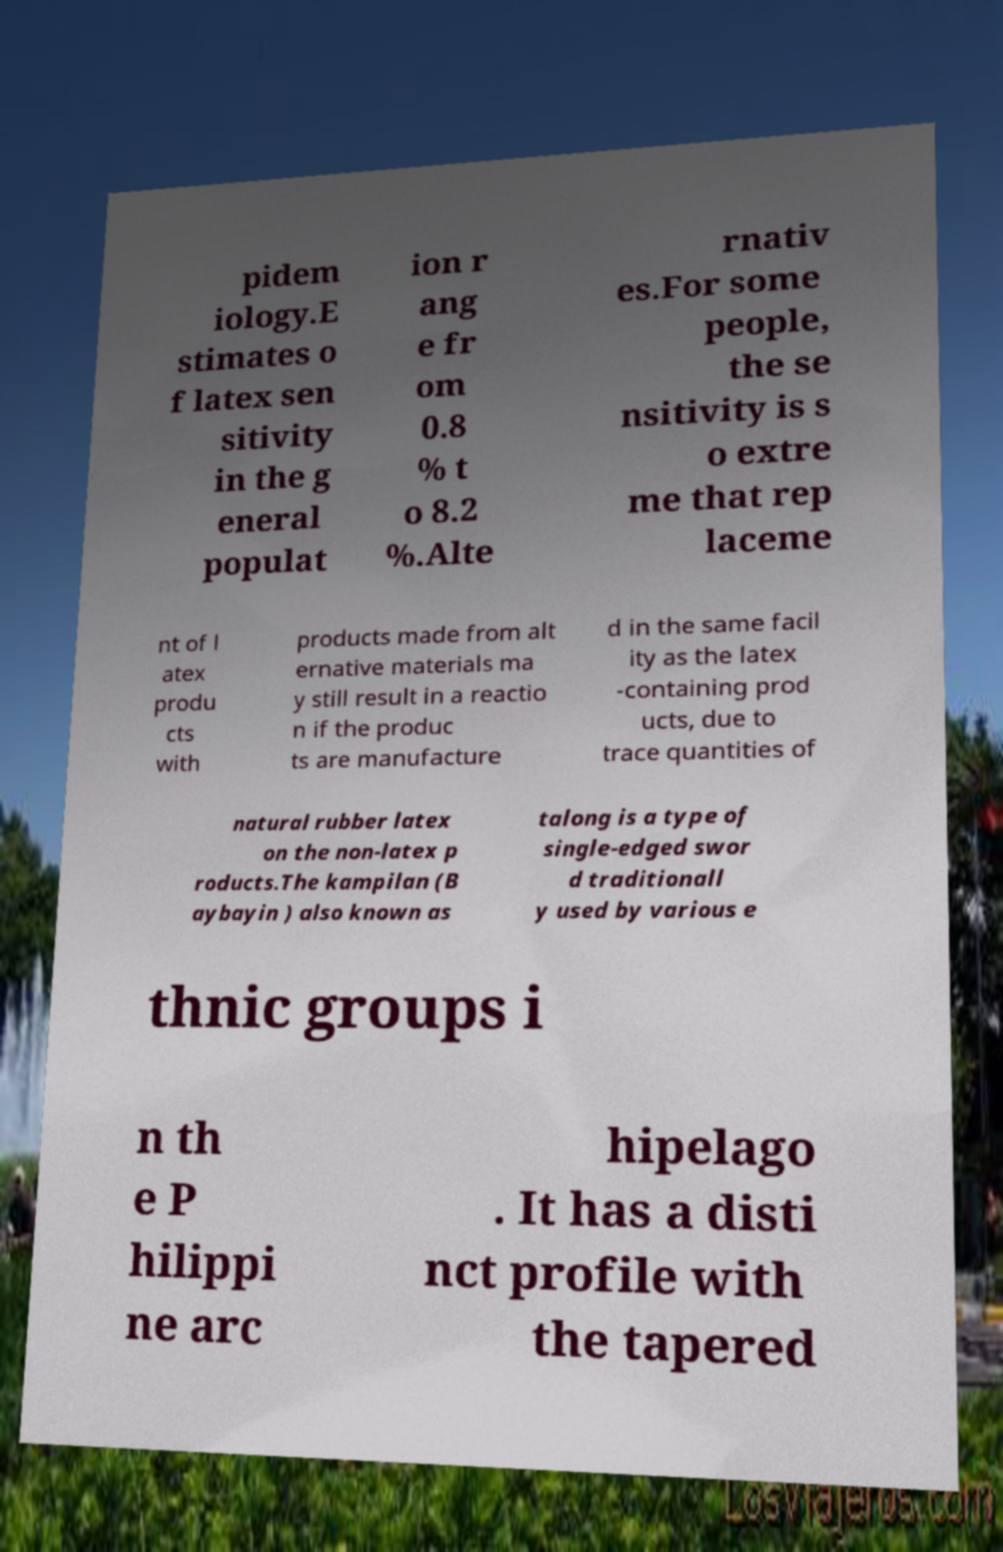For documentation purposes, I need the text within this image transcribed. Could you provide that? pidem iology.E stimates o f latex sen sitivity in the g eneral populat ion r ang e fr om 0.8 % t o 8.2 %.Alte rnativ es.For some people, the se nsitivity is s o extre me that rep laceme nt of l atex produ cts with products made from alt ernative materials ma y still result in a reactio n if the produc ts are manufacture d in the same facil ity as the latex -containing prod ucts, due to trace quantities of natural rubber latex on the non-latex p roducts.The kampilan (B aybayin ) also known as talong is a type of single-edged swor d traditionall y used by various e thnic groups i n th e P hilippi ne arc hipelago . It has a disti nct profile with the tapered 